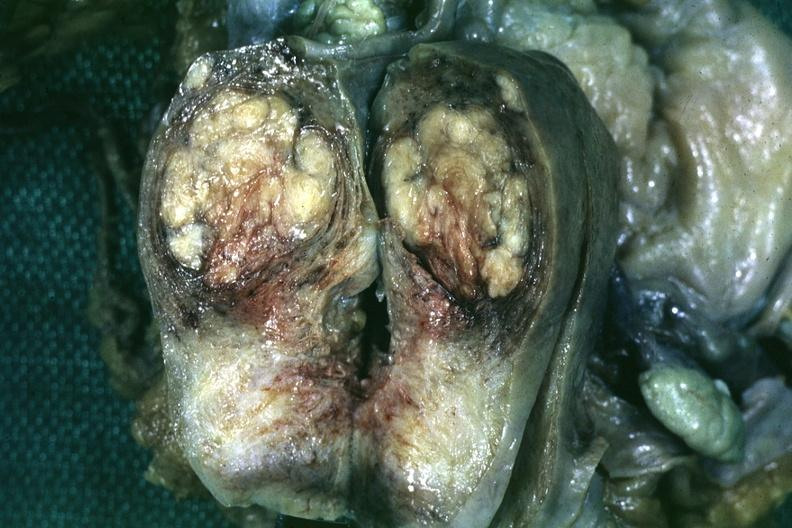what is present?
Answer the question using a single word or phrase. Uterus 